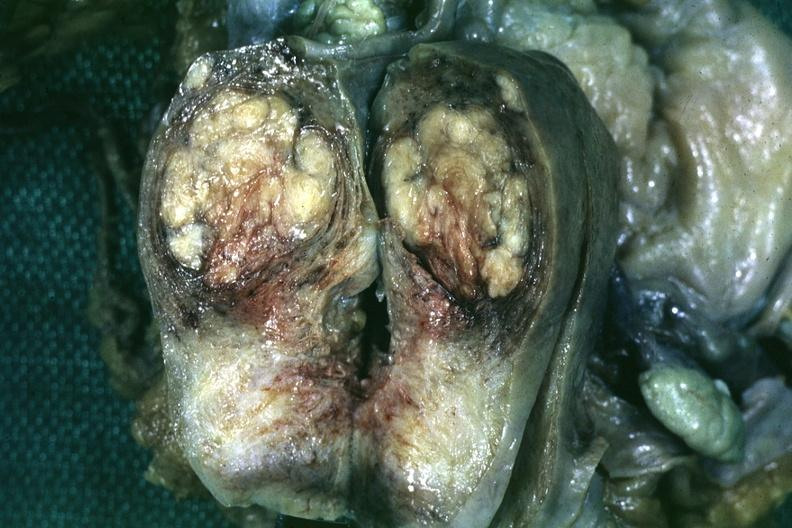what is present?
Answer the question using a single word or phrase. Uterus 